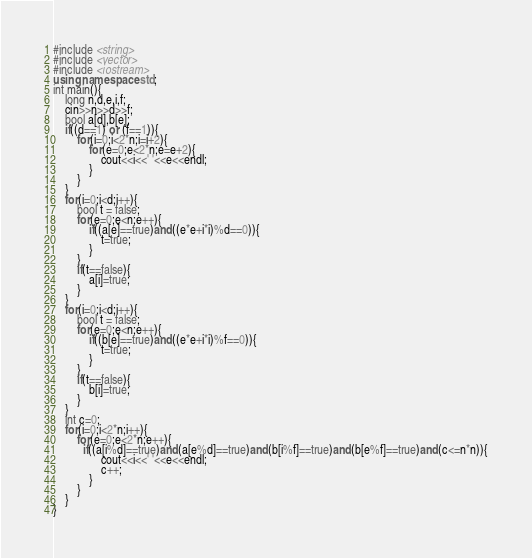Convert code to text. <code><loc_0><loc_0><loc_500><loc_500><_C++_>#include <string>
#include <vector>
#include <iostream>
using namespace std;
int main(){
    long n,d,e,i,f;
    cin>>n>>d>>f;
    bool a[d],b[e];
    if((d==1) or (f==1)){
        for(i=0;i<2*n;i=i+2){
            for(e=0;e<2*n;e=e+2){
                cout<<i<<' '<<e<<endl;
            }
        }
    }
    for(i=0;i<d;i++){
        bool t = false;
        for(e=0;e<n;e++){
            if((a[e]==true)and((e*e+i*i)%d==0)){
                t=true;
            }
        }
        if(t==false){
            a[i]=true;
        }
    }
    for(i=0;i<d;i++){
        bool t = false;
        for(e=0;e<n;e++){
            if((b[e]==true)and((e*e+i*i)%f==0)){
                t=true;
            }
        }
        if(t==false){
            b[i]=true;
        }
    }
    int c=0;
    for(i=0;i<2*n;i++){
        for(e=0;e<2*n;e++){
          if((a[i%d]==true)and(a[e%d]==true)and(b[i%f]==true)and(b[e%f]==true)and(c<=n*n)){
                cout<<i<<' '<<e<<endl;
                c++;
            }
        }
    }
}</code> 